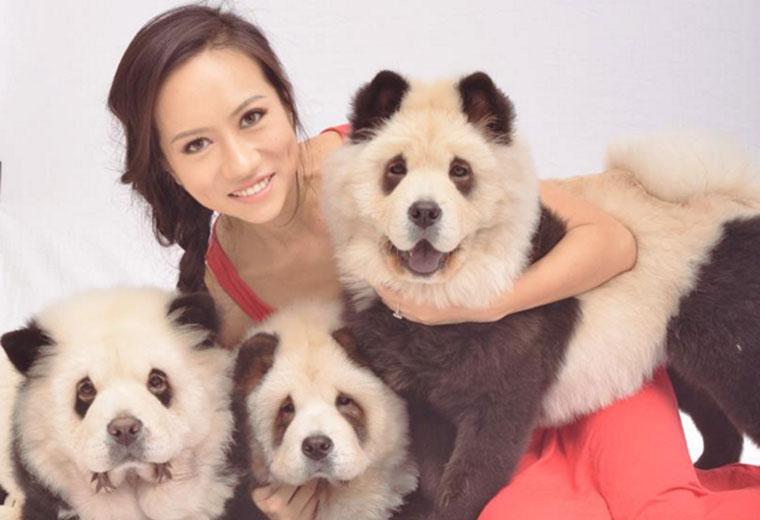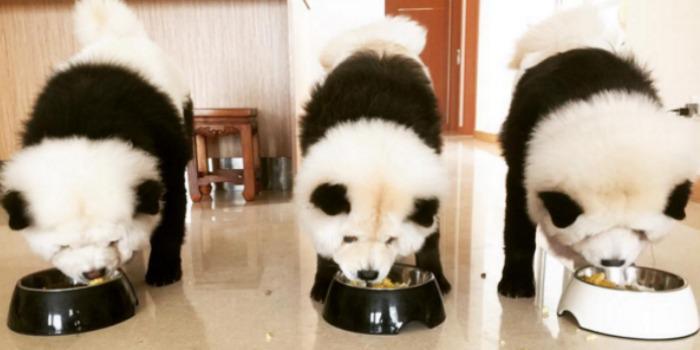The first image is the image on the left, the second image is the image on the right. For the images shown, is this caption "A woman is hugging dogs dyes to look like pandas" true? Answer yes or no. Yes. The first image is the image on the left, the second image is the image on the right. For the images shown, is this caption "In one image, a woman poses with three dogs" true? Answer yes or no. Yes. 